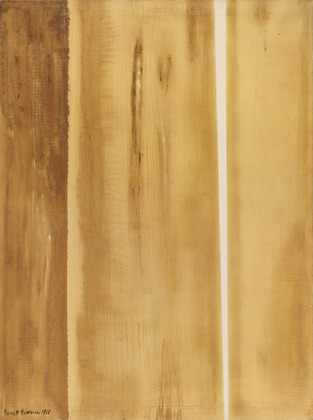What do you think the artist was trying to convey with this piece? Barnett Newman, through this piece, might have been trying to convey the profound simplicity of natural forms and the intricacies of our perceptions of them. The use of color and texture reflects a deep connection to earthy elements, perhaps suggesting a return to basics or a search for authenticity and grounding. The vertical lines could symbolize life’s structures—both natural and human-made—that we rely upon yet which can be irregular and imperfect. This work invites viewers to explore the beauty in simplicity and the complexity underlying it. 